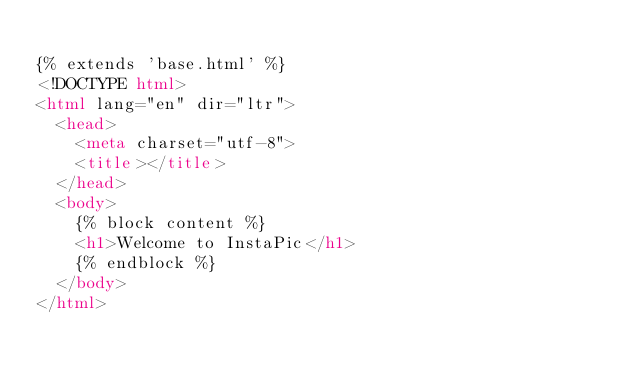<code> <loc_0><loc_0><loc_500><loc_500><_HTML_>
{% extends 'base.html' %}
<!DOCTYPE html>
<html lang="en" dir="ltr">
  <head>
    <meta charset="utf-8">
    <title></title>
  </head>
  <body>
    {% block content %}
    <h1>Welcome to InstaPic</h1>
    {% endblock %}
  </body>
</html>
</code> 